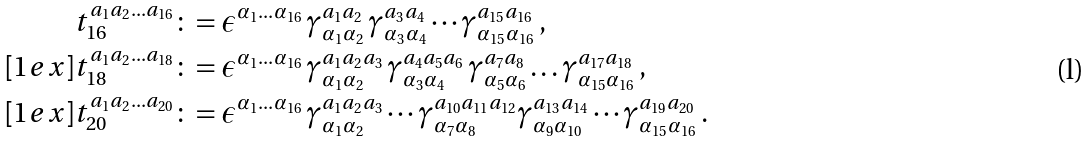<formula> <loc_0><loc_0><loc_500><loc_500>t _ { 1 6 } ^ { a _ { 1 } a _ { 2 } \dots a _ { 1 6 } } & \colon = \epsilon ^ { \alpha _ { 1 } \dots \alpha _ { 1 6 } } \, \gamma ^ { a _ { 1 } a _ { 2 } } _ { \alpha _ { 1 } \alpha _ { 2 } } \, \gamma ^ { a _ { 3 } a _ { 4 } } _ { \alpha _ { 3 } \alpha _ { 4 } } \cdots \gamma ^ { a _ { 1 5 } a _ { 1 6 } } _ { \alpha _ { 1 5 } \alpha _ { 1 6 } } \, , \\ [ 1 e x ] t _ { 1 8 } ^ { a _ { 1 } a _ { 2 } \dots a _ { 1 8 } } & \colon = \epsilon ^ { \alpha _ { 1 } \dots \alpha _ { 1 6 } } \, \gamma _ { \alpha _ { 1 } \alpha _ { 2 } } ^ { a _ { 1 } a _ { 2 } a _ { 3 } } \, \gamma _ { \alpha _ { 3 } \alpha _ { 4 } } ^ { a _ { 4 } a _ { 5 } a _ { 6 } } \, \gamma _ { \alpha _ { 5 } \alpha _ { 6 } } ^ { a _ { 7 } a _ { 8 } } \dots \gamma _ { \alpha _ { 1 5 } \alpha _ { 1 6 } } ^ { a _ { 1 7 } a _ { 1 8 } } \, , \\ [ 1 e x ] t _ { 2 0 } ^ { a _ { 1 } a _ { 2 } \dots a _ { 2 0 } } & \colon = \epsilon ^ { \alpha _ { 1 } \dots \alpha _ { 1 6 } } \, \gamma _ { \alpha _ { 1 } \alpha _ { 2 } } ^ { a _ { 1 } a _ { 2 } a _ { 3 } } \cdots \gamma _ { \alpha _ { 7 } \alpha _ { 8 } } ^ { a _ { 1 0 } a _ { 1 1 } a _ { 1 2 } } \gamma _ { \alpha _ { 9 } \alpha _ { 1 0 } } ^ { a _ { 1 3 } a _ { 1 4 } } \cdots \gamma _ { \alpha _ { 1 5 } \alpha _ { 1 6 } } ^ { a _ { 1 9 } a _ { 2 0 } } \, .</formula> 